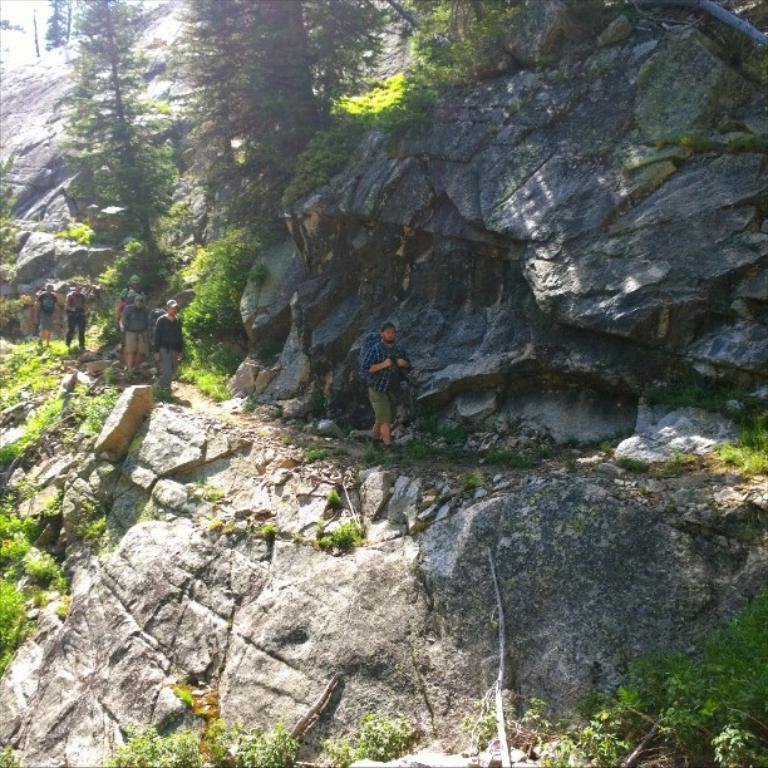Who or what can be seen in the image? There are people in the image. What type of natural features are present in the image? There are rock hills, grass, plants, and trees in the image. What type of attention is the cow receiving in the image? There is no cow present in the image, so it is not possible to determine what type of attention it might be receiving. 